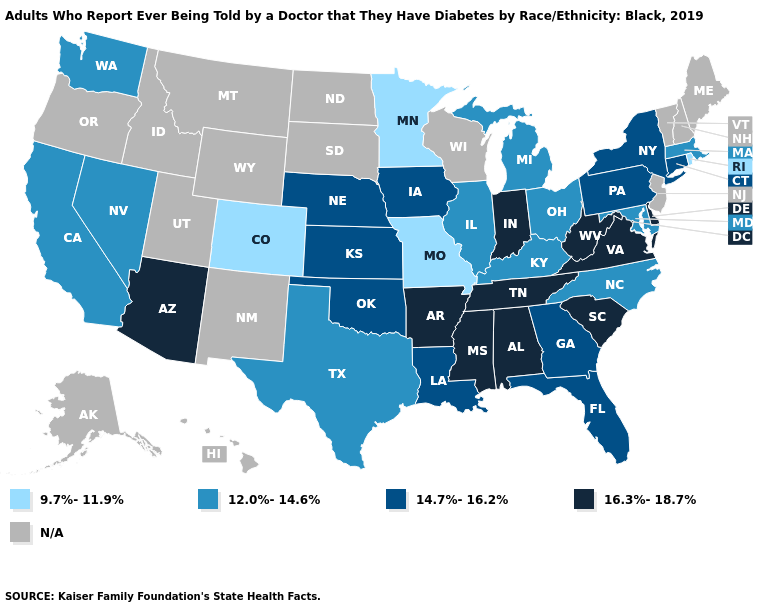What is the highest value in the USA?
Be succinct. 16.3%-18.7%. Name the states that have a value in the range 9.7%-11.9%?
Short answer required. Colorado, Minnesota, Missouri, Rhode Island. Name the states that have a value in the range 14.7%-16.2%?
Short answer required. Connecticut, Florida, Georgia, Iowa, Kansas, Louisiana, Nebraska, New York, Oklahoma, Pennsylvania. What is the value of Wyoming?
Write a very short answer. N/A. What is the lowest value in states that border Louisiana?
Concise answer only. 12.0%-14.6%. What is the value of Alaska?
Concise answer only. N/A. How many symbols are there in the legend?
Answer briefly. 5. Name the states that have a value in the range 12.0%-14.6%?
Give a very brief answer. California, Illinois, Kentucky, Maryland, Massachusetts, Michigan, Nevada, North Carolina, Ohio, Texas, Washington. Does Pennsylvania have the lowest value in the Northeast?
Be succinct. No. Among the states that border Virginia , does Tennessee have the highest value?
Answer briefly. Yes. Name the states that have a value in the range 16.3%-18.7%?
Quick response, please. Alabama, Arizona, Arkansas, Delaware, Indiana, Mississippi, South Carolina, Tennessee, Virginia, West Virginia. Name the states that have a value in the range 16.3%-18.7%?
Short answer required. Alabama, Arizona, Arkansas, Delaware, Indiana, Mississippi, South Carolina, Tennessee, Virginia, West Virginia. Name the states that have a value in the range 14.7%-16.2%?
Give a very brief answer. Connecticut, Florida, Georgia, Iowa, Kansas, Louisiana, Nebraska, New York, Oklahoma, Pennsylvania. What is the value of Texas?
Answer briefly. 12.0%-14.6%. Name the states that have a value in the range 9.7%-11.9%?
Write a very short answer. Colorado, Minnesota, Missouri, Rhode Island. 